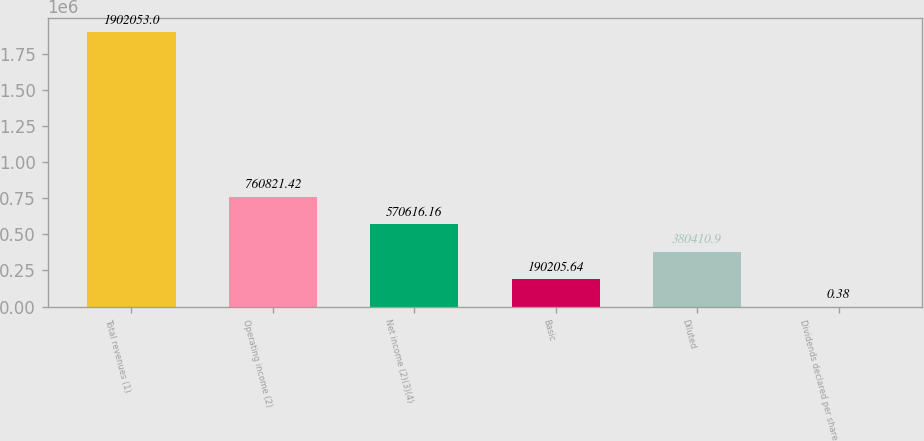Convert chart. <chart><loc_0><loc_0><loc_500><loc_500><bar_chart><fcel>Total revenues (1)<fcel>Operating income (2)<fcel>Net income (2)(3)(4)<fcel>Basic<fcel>Diluted<fcel>Dividends declared per share<nl><fcel>1.90205e+06<fcel>760821<fcel>570616<fcel>190206<fcel>380411<fcel>0.38<nl></chart> 